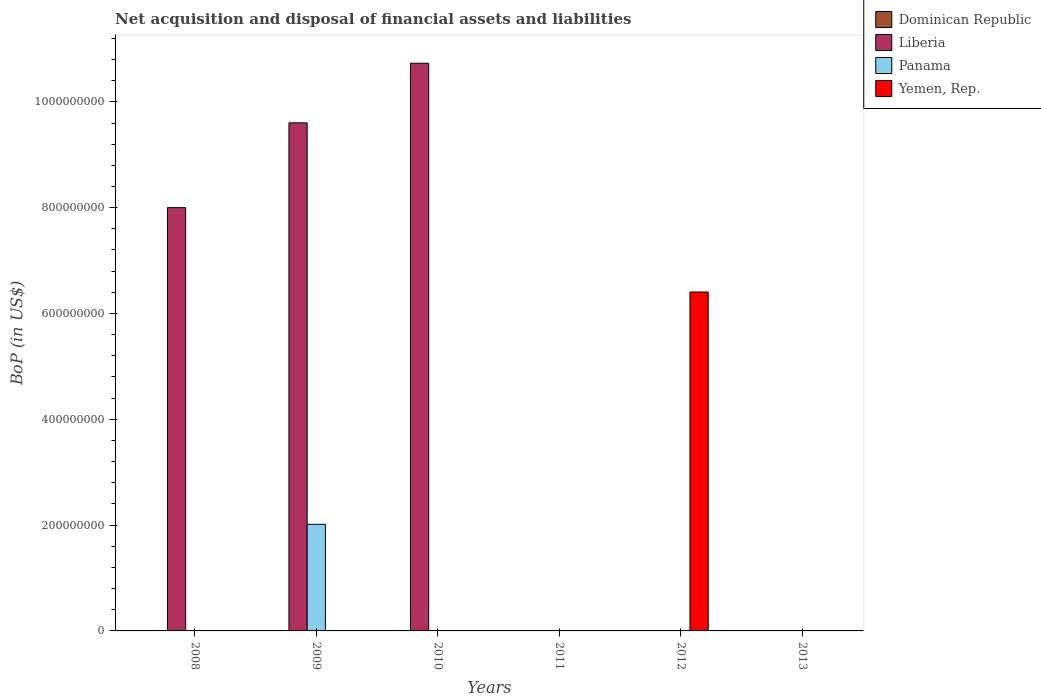How many different coloured bars are there?
Your answer should be compact. 3. Are the number of bars per tick equal to the number of legend labels?
Your response must be concise. No. What is the label of the 1st group of bars from the left?
Give a very brief answer. 2008. In how many cases, is the number of bars for a given year not equal to the number of legend labels?
Your answer should be very brief. 6. What is the Balance of Payments in Yemen, Rep. in 2008?
Offer a terse response. 0. Across all years, what is the maximum Balance of Payments in Liberia?
Keep it short and to the point. 1.07e+09. In which year was the Balance of Payments in Panama maximum?
Your answer should be very brief. 2009. What is the difference between the Balance of Payments in Liberia in 2008 and that in 2010?
Provide a succinct answer. -2.73e+08. What is the average Balance of Payments in Yemen, Rep. per year?
Offer a terse response. 1.07e+08. What is the difference between the highest and the second highest Balance of Payments in Liberia?
Offer a terse response. 1.13e+08. What is the difference between the highest and the lowest Balance of Payments in Liberia?
Your response must be concise. 1.07e+09. Is it the case that in every year, the sum of the Balance of Payments in Yemen, Rep. and Balance of Payments in Liberia is greater than the sum of Balance of Payments in Panama and Balance of Payments in Dominican Republic?
Provide a succinct answer. No. Are the values on the major ticks of Y-axis written in scientific E-notation?
Your answer should be compact. No. Does the graph contain any zero values?
Offer a very short reply. Yes. Where does the legend appear in the graph?
Offer a very short reply. Top right. How many legend labels are there?
Give a very brief answer. 4. What is the title of the graph?
Your response must be concise. Net acquisition and disposal of financial assets and liabilities. Does "Marshall Islands" appear as one of the legend labels in the graph?
Your answer should be very brief. No. What is the label or title of the X-axis?
Keep it short and to the point. Years. What is the label or title of the Y-axis?
Offer a very short reply. BoP (in US$). What is the BoP (in US$) in Dominican Republic in 2008?
Keep it short and to the point. 0. What is the BoP (in US$) in Liberia in 2008?
Offer a very short reply. 8.00e+08. What is the BoP (in US$) in Panama in 2008?
Provide a succinct answer. 0. What is the BoP (in US$) in Yemen, Rep. in 2008?
Your response must be concise. 0. What is the BoP (in US$) of Dominican Republic in 2009?
Your response must be concise. 0. What is the BoP (in US$) in Liberia in 2009?
Your answer should be very brief. 9.60e+08. What is the BoP (in US$) of Panama in 2009?
Make the answer very short. 2.02e+08. What is the BoP (in US$) of Yemen, Rep. in 2009?
Offer a very short reply. 0. What is the BoP (in US$) in Liberia in 2010?
Offer a terse response. 1.07e+09. What is the BoP (in US$) of Panama in 2010?
Offer a terse response. 0. What is the BoP (in US$) in Dominican Republic in 2011?
Make the answer very short. 0. What is the BoP (in US$) of Liberia in 2011?
Offer a very short reply. 0. What is the BoP (in US$) of Yemen, Rep. in 2011?
Your answer should be very brief. 0. What is the BoP (in US$) in Panama in 2012?
Your answer should be compact. 0. What is the BoP (in US$) of Yemen, Rep. in 2012?
Offer a very short reply. 6.41e+08. What is the BoP (in US$) in Liberia in 2013?
Offer a terse response. 0. What is the BoP (in US$) of Panama in 2013?
Keep it short and to the point. 0. Across all years, what is the maximum BoP (in US$) in Liberia?
Provide a short and direct response. 1.07e+09. Across all years, what is the maximum BoP (in US$) in Panama?
Your answer should be compact. 2.02e+08. Across all years, what is the maximum BoP (in US$) of Yemen, Rep.?
Your answer should be very brief. 6.41e+08. Across all years, what is the minimum BoP (in US$) of Liberia?
Keep it short and to the point. 0. Across all years, what is the minimum BoP (in US$) in Panama?
Your response must be concise. 0. What is the total BoP (in US$) in Dominican Republic in the graph?
Your response must be concise. 0. What is the total BoP (in US$) in Liberia in the graph?
Provide a short and direct response. 2.83e+09. What is the total BoP (in US$) of Panama in the graph?
Ensure brevity in your answer.  2.02e+08. What is the total BoP (in US$) of Yemen, Rep. in the graph?
Give a very brief answer. 6.41e+08. What is the difference between the BoP (in US$) of Liberia in 2008 and that in 2009?
Your response must be concise. -1.60e+08. What is the difference between the BoP (in US$) of Liberia in 2008 and that in 2010?
Your answer should be very brief. -2.73e+08. What is the difference between the BoP (in US$) of Liberia in 2009 and that in 2010?
Provide a short and direct response. -1.13e+08. What is the difference between the BoP (in US$) of Liberia in 2008 and the BoP (in US$) of Panama in 2009?
Offer a very short reply. 5.99e+08. What is the difference between the BoP (in US$) of Liberia in 2008 and the BoP (in US$) of Yemen, Rep. in 2012?
Make the answer very short. 1.59e+08. What is the difference between the BoP (in US$) of Liberia in 2009 and the BoP (in US$) of Yemen, Rep. in 2012?
Your response must be concise. 3.20e+08. What is the difference between the BoP (in US$) of Panama in 2009 and the BoP (in US$) of Yemen, Rep. in 2012?
Ensure brevity in your answer.  -4.39e+08. What is the difference between the BoP (in US$) in Liberia in 2010 and the BoP (in US$) in Yemen, Rep. in 2012?
Give a very brief answer. 4.32e+08. What is the average BoP (in US$) in Liberia per year?
Offer a terse response. 4.72e+08. What is the average BoP (in US$) in Panama per year?
Make the answer very short. 3.36e+07. What is the average BoP (in US$) of Yemen, Rep. per year?
Offer a very short reply. 1.07e+08. In the year 2009, what is the difference between the BoP (in US$) of Liberia and BoP (in US$) of Panama?
Ensure brevity in your answer.  7.59e+08. What is the ratio of the BoP (in US$) of Liberia in 2008 to that in 2009?
Your response must be concise. 0.83. What is the ratio of the BoP (in US$) of Liberia in 2008 to that in 2010?
Your answer should be compact. 0.75. What is the ratio of the BoP (in US$) of Liberia in 2009 to that in 2010?
Your answer should be very brief. 0.9. What is the difference between the highest and the second highest BoP (in US$) of Liberia?
Your answer should be compact. 1.13e+08. What is the difference between the highest and the lowest BoP (in US$) in Liberia?
Offer a very short reply. 1.07e+09. What is the difference between the highest and the lowest BoP (in US$) in Panama?
Provide a short and direct response. 2.02e+08. What is the difference between the highest and the lowest BoP (in US$) in Yemen, Rep.?
Ensure brevity in your answer.  6.41e+08. 